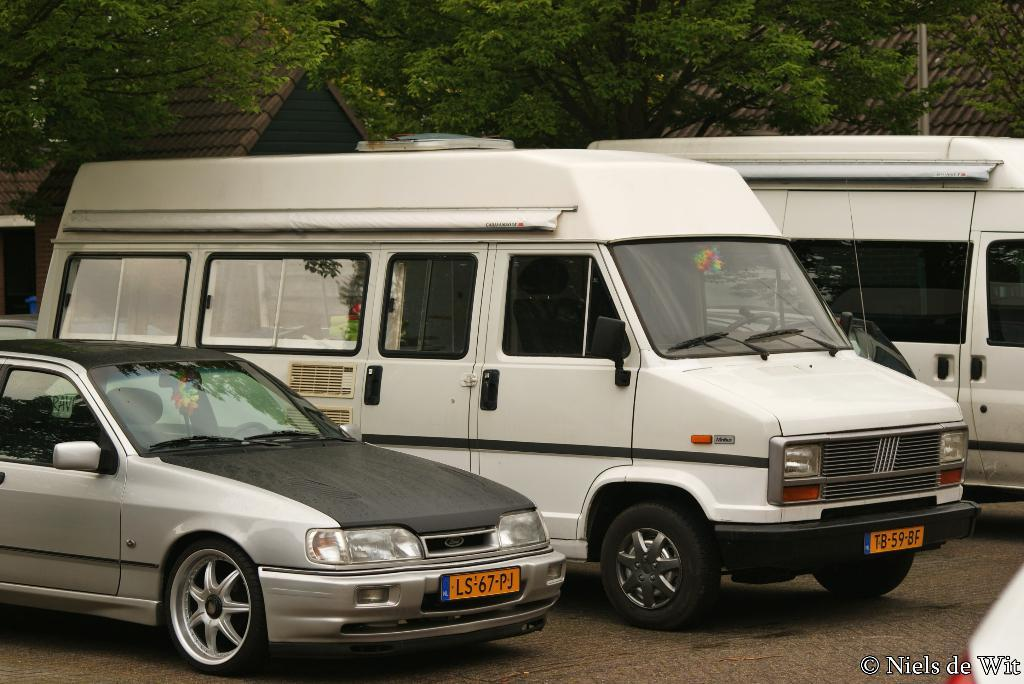<image>
Give a short and clear explanation of the subsequent image. the license plate that says LS on the front 